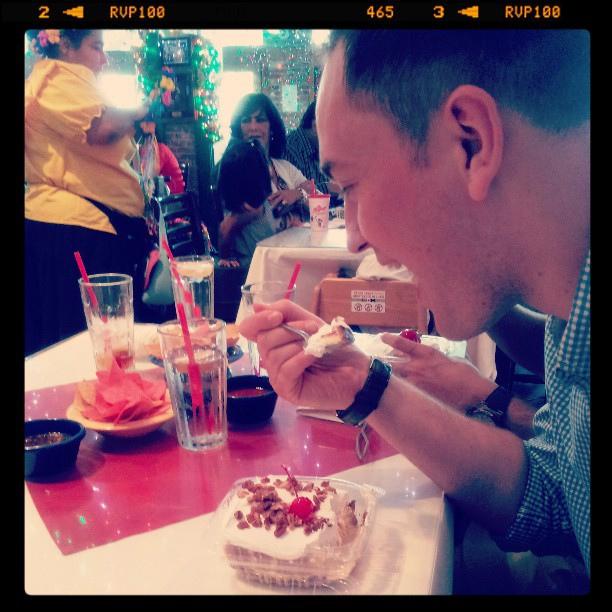Will this dessert fill this man up?
Give a very brief answer. Yes. What color shirt is the lady in the back left wearing?
Be succinct. Yellow. Is the woman in yellow of normal weight?
Keep it brief. No. 